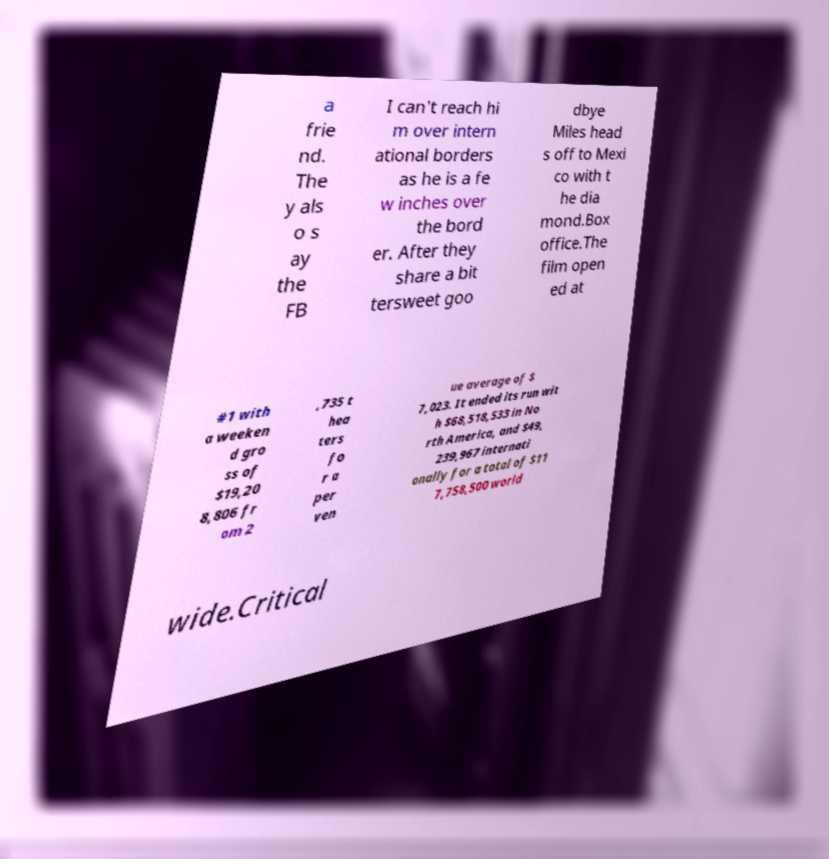Please read and relay the text visible in this image. What does it say? a frie nd. The y als o s ay the FB I can't reach hi m over intern ational borders as he is a fe w inches over the bord er. After they share a bit tersweet goo dbye Miles head s off to Mexi co with t he dia mond.Box office.The film open ed at #1 with a weeken d gro ss of $19,20 8,806 fr om 2 ,735 t hea ters fo r a per ven ue average of $ 7,023. It ended its run wit h $68,518,533 in No rth America, and $49, 239,967 internati onally for a total of $11 7,758,500 world wide.Critical 